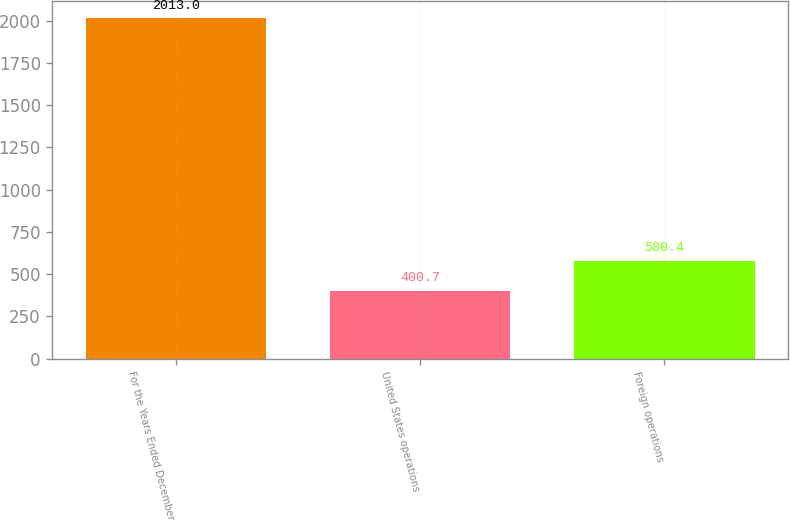Convert chart. <chart><loc_0><loc_0><loc_500><loc_500><bar_chart><fcel>For the Years Ended December<fcel>United States operations<fcel>Foreign operations<nl><fcel>2013<fcel>400.7<fcel>580.4<nl></chart> 